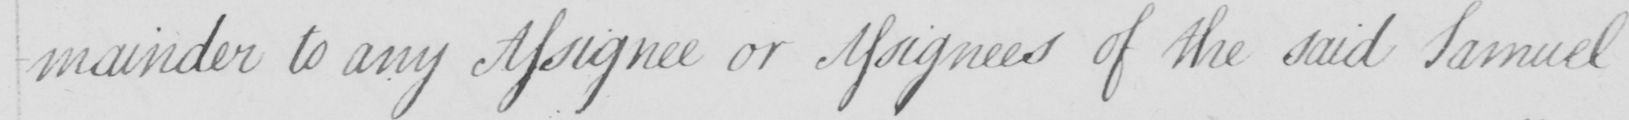Can you read and transcribe this handwriting? -mainder to any Assignee or Assignees of the said Samuel 